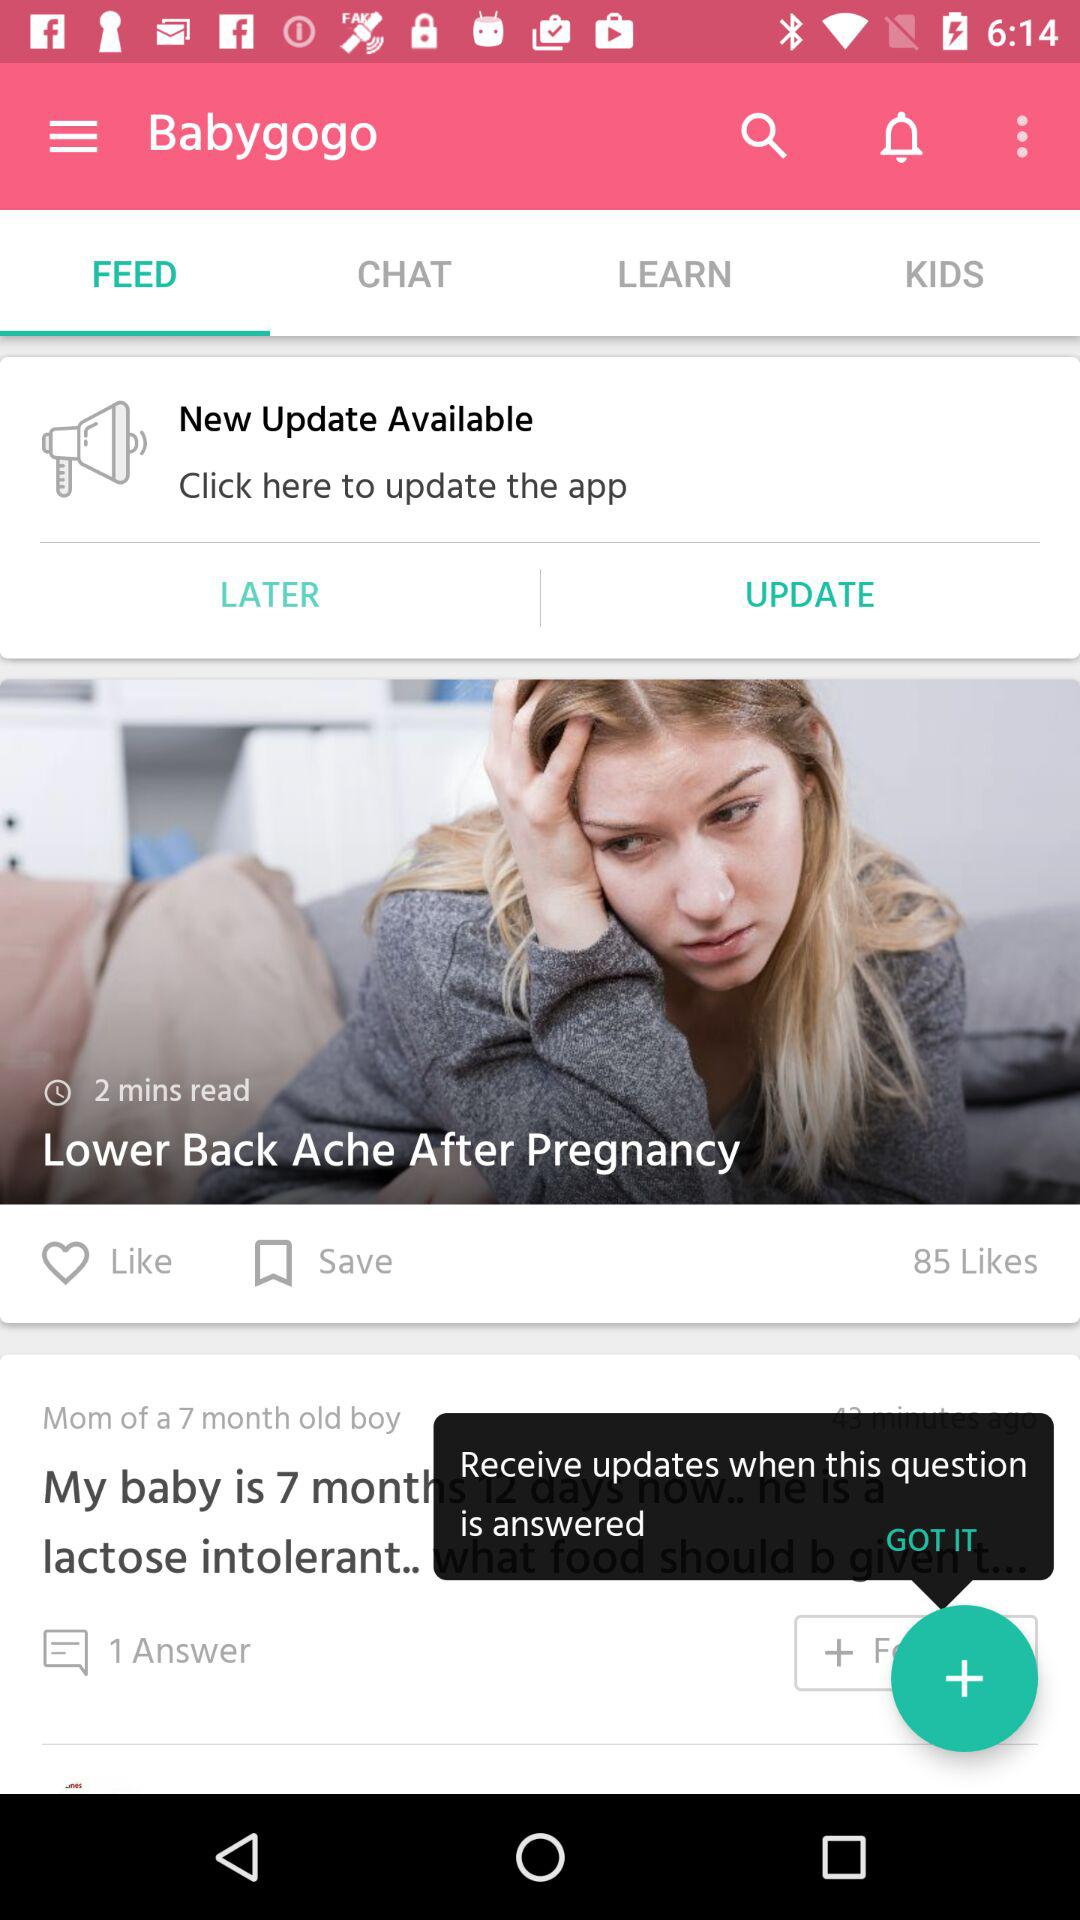How many answers are there to the question?
Answer the question using a single word or phrase. 1 